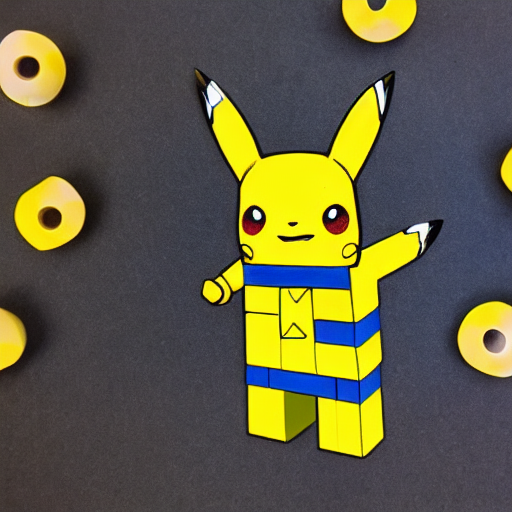How is the focus of the image?
A. Precise and clear with no noticeable noise.
B. Out of focus and noisy.
C. Blurry and with noticeable noise.
Answer with the option's letter from the given choices directly.
 A. 